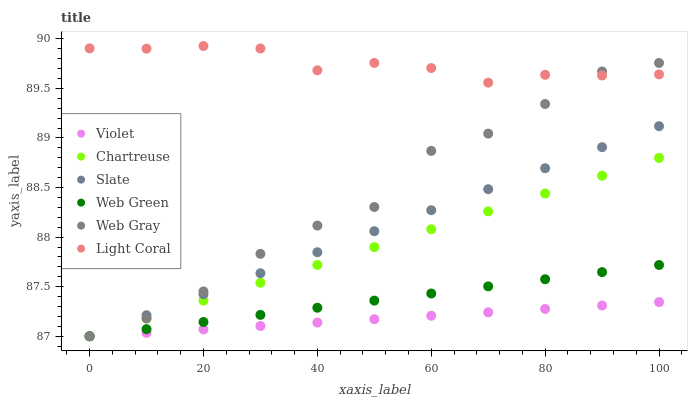Does Violet have the minimum area under the curve?
Answer yes or no. Yes. Does Light Coral have the maximum area under the curve?
Answer yes or no. Yes. Does Slate have the minimum area under the curve?
Answer yes or no. No. Does Slate have the maximum area under the curve?
Answer yes or no. No. Is Slate the smoothest?
Answer yes or no. Yes. Is Web Gray the roughest?
Answer yes or no. Yes. Is Web Green the smoothest?
Answer yes or no. No. Is Web Green the roughest?
Answer yes or no. No. Does Web Gray have the lowest value?
Answer yes or no. Yes. Does Light Coral have the lowest value?
Answer yes or no. No. Does Light Coral have the highest value?
Answer yes or no. Yes. Does Slate have the highest value?
Answer yes or no. No. Is Web Green less than Light Coral?
Answer yes or no. Yes. Is Light Coral greater than Chartreuse?
Answer yes or no. Yes. Does Web Gray intersect Light Coral?
Answer yes or no. Yes. Is Web Gray less than Light Coral?
Answer yes or no. No. Is Web Gray greater than Light Coral?
Answer yes or no. No. Does Web Green intersect Light Coral?
Answer yes or no. No. 